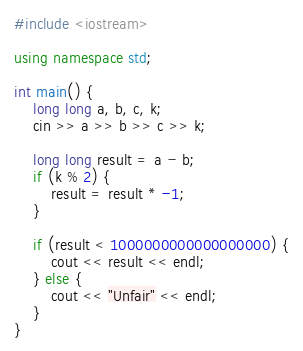<code> <loc_0><loc_0><loc_500><loc_500><_C++_>#include <iostream>

using namespace std;

int main() {
	long long a, b, c, k;
	cin >> a >> b >> c >> k;
	
	long long result = a - b;
	if (k % 2) {
		result = result * -1;
	}
	
	if (result < 1000000000000000000) {
		cout << result << endl;
	} else {
		cout << "Unfair" << endl;
	}
}</code> 